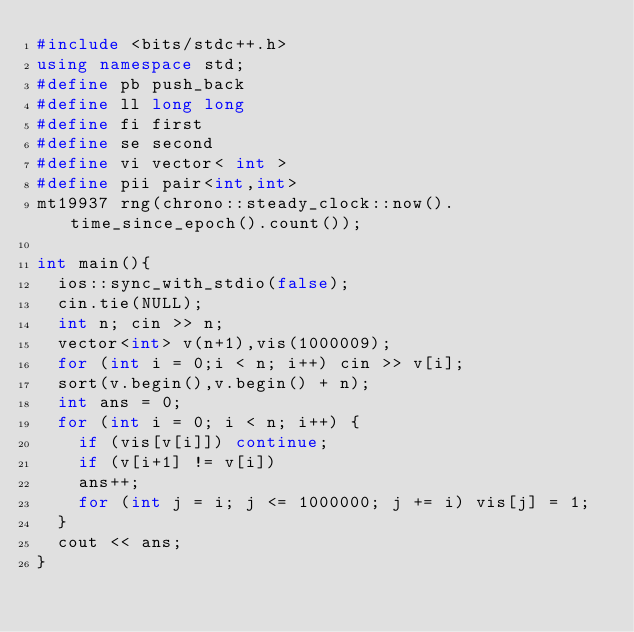<code> <loc_0><loc_0><loc_500><loc_500><_C++_>#include <bits/stdc++.h>
using namespace std;
#define pb push_back
#define ll long long
#define fi first
#define se second
#define vi vector< int > 
#define pii pair<int,int>
mt19937 rng(chrono::steady_clock::now().time_since_epoch().count());

int main(){
	ios::sync_with_stdio(false);
	cin.tie(NULL);
	int n; cin >> n;
	vector<int> v(n+1),vis(1000009);
	for (int i = 0;i < n; i++) cin >> v[i];
	sort(v.begin(),v.begin() + n);
	int ans = 0;
	for (int i = 0; i < n; i++) {
		if (vis[v[i]]) continue;
		if (v[i+1] != v[i])
		ans++;
		for (int j = i; j <= 1000000; j += i) vis[j] = 1;
	}
	cout << ans;
}</code> 